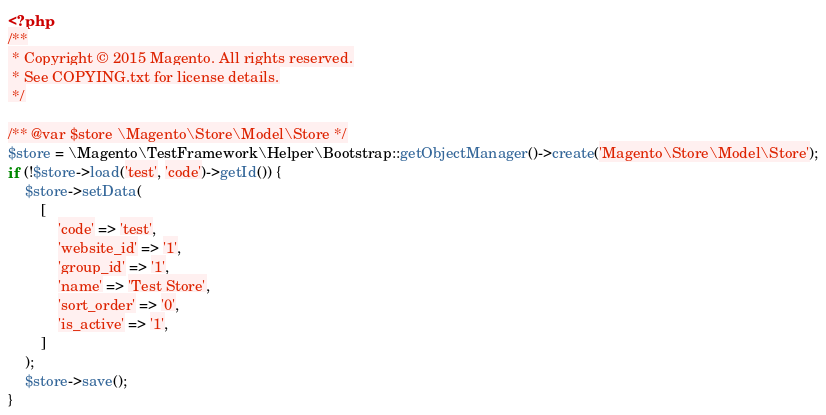<code> <loc_0><loc_0><loc_500><loc_500><_PHP_><?php
/**
 * Copyright © 2015 Magento. All rights reserved.
 * See COPYING.txt for license details.
 */

/** @var $store \Magento\Store\Model\Store */
$store = \Magento\TestFramework\Helper\Bootstrap::getObjectManager()->create('Magento\Store\Model\Store');
if (!$store->load('test', 'code')->getId()) {
    $store->setData(
        [
            'code' => 'test',
            'website_id' => '1',
            'group_id' => '1',
            'name' => 'Test Store',
            'sort_order' => '0',
            'is_active' => '1',
        ]
    );
    $store->save();
}
</code> 